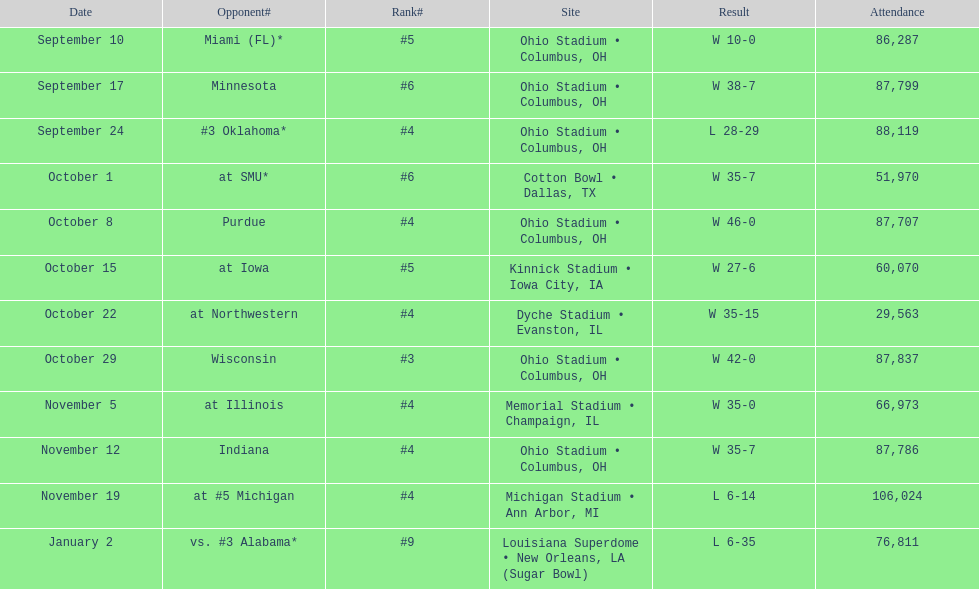How many games had a crowd of over 80,000 people? 7. 